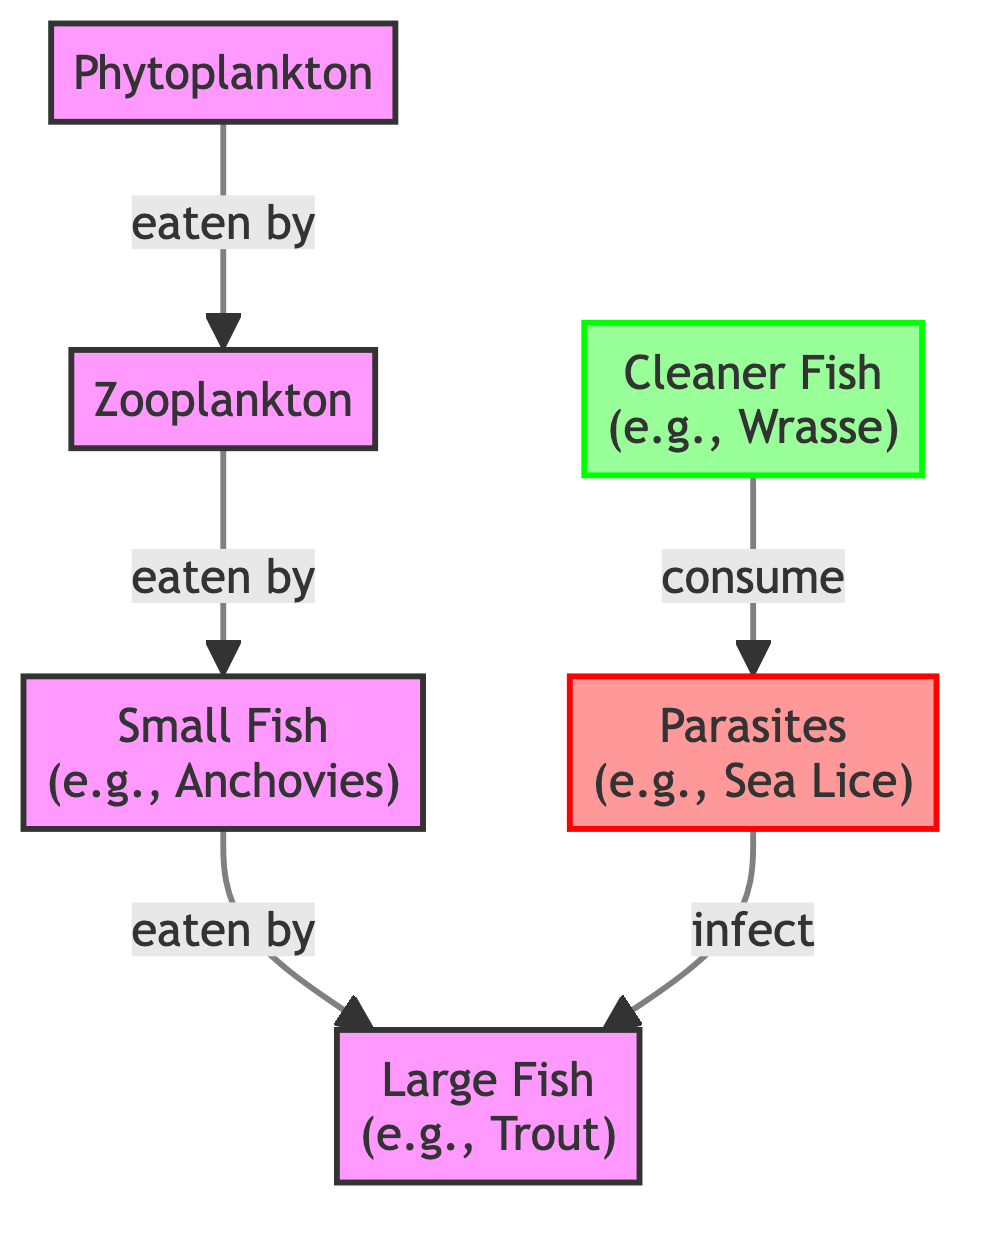What's the top node in the food chain? The top node in the food chain is large fish, as it is at the end of the chain with no other entities consuming it.
Answer: Large Fish How many types of fish are represented in the diagram? There are two types of fish represented: small fish and large fish. This is determined by counting the fish nodes shown in the diagram.
Answer: Two What do cleaner fish consume? Cleaner fish consume parasites, which is directly indicated by the directional relationship between cleaner fish and parasites in the diagram.
Answer: Parasites Which organism is infected by parasites? Large fish are infected by parasites, as shown by the directional arrow leading from the parasites node towards the large fish node.
Answer: Large Fish What is the relationship between zooplankton and small fish? Zooplankton is eaten by small fish, as indicated by the arrow that links zooplankton to small fish in the diagram.
Answer: Eaten by How does the food chain demonstrate the role of parasites? The food chain shows that parasites infect large fish, which is a negative impact on the large fish, illustrating the significance of parasite management in aquaculture.
Answer: Infect large fish How many total nodes are present in the diagram? The diagram displays six nodes: phytoplankton, zooplankton, small fish, large fish, parasites, and cleaner fish. Adding up these distinct nodes gives the total count.
Answer: Six What is the flow of energy from phytoplankton to large fish? The flow begins with phytoplankton being eaten by zooplankton, which are then eaten by small fish, finally leading to large fish consuming the small fish.
Answer: Phytoplankton → Zooplankton → Small Fish → Large Fish What role do cleaner fish play in this food chain? Cleaner fish act as a natural control by consuming parasites that infect large fish, helping to manage the parasite population in the aquaculture environment.
Answer: Consume parasites 